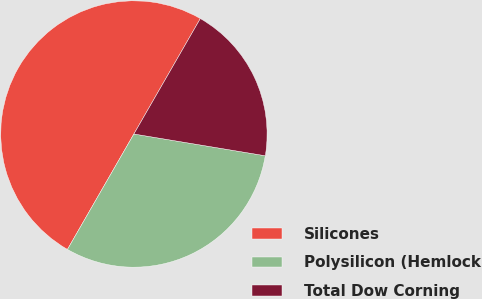Convert chart to OTSL. <chart><loc_0><loc_0><loc_500><loc_500><pie_chart><fcel>Silicones<fcel>Polysilicon (Hemlock<fcel>Total Dow Corning<nl><fcel>50.0%<fcel>30.7%<fcel>19.3%<nl></chart> 